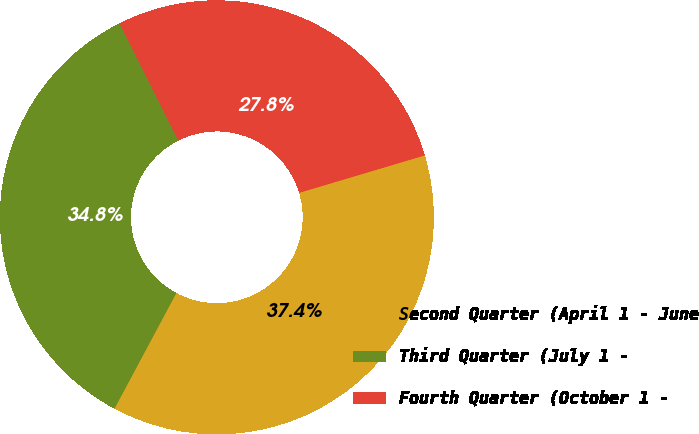<chart> <loc_0><loc_0><loc_500><loc_500><pie_chart><fcel>Second Quarter (April 1 - June<fcel>Third Quarter (July 1 -<fcel>Fourth Quarter (October 1 -<nl><fcel>37.43%<fcel>34.79%<fcel>27.78%<nl></chart> 